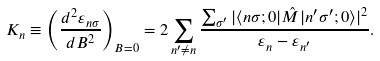Convert formula to latex. <formula><loc_0><loc_0><loc_500><loc_500>K _ { n } \equiv \left ( \frac { d ^ { 2 } \varepsilon _ { n \sigma } } { d B ^ { 2 } } \right ) _ { B = 0 } = 2 \sum _ { n ^ { \prime } \neq n } \frac { \sum _ { \sigma ^ { \prime } } | \langle n \sigma ; 0 | \hat { M } | n ^ { \prime } \sigma ^ { \prime } ; 0 \rangle | ^ { 2 } } { \varepsilon _ { n } - \varepsilon _ { n ^ { \prime } } } .</formula> 